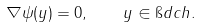Convert formula to latex. <formula><loc_0><loc_0><loc_500><loc_500>\nabla \psi ( y ) = 0 , \quad y \in \i d c h .</formula> 